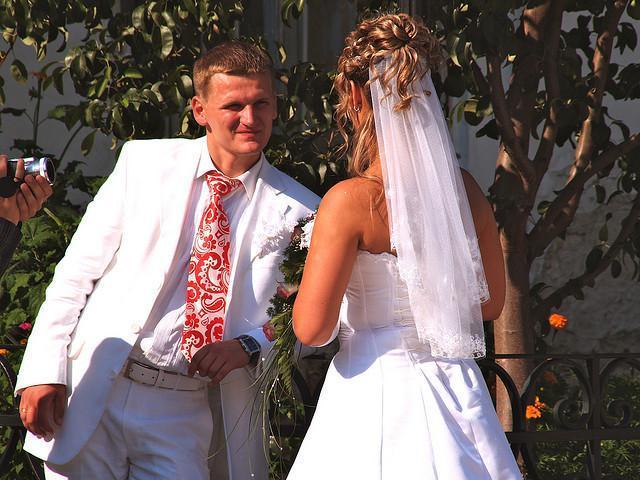How many people are there?
Give a very brief answer. 3. 